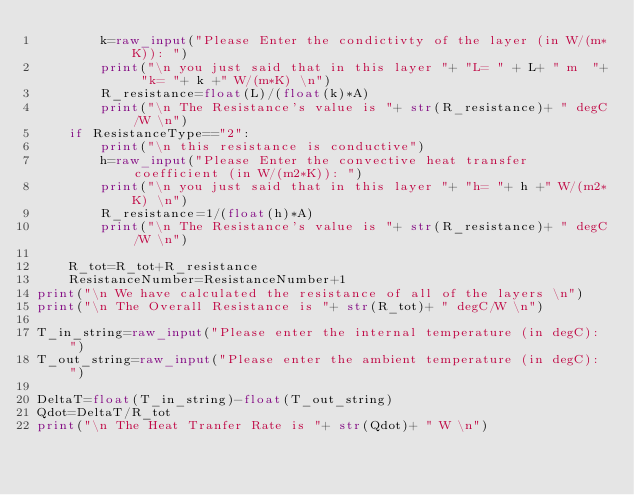Convert code to text. <code><loc_0><loc_0><loc_500><loc_500><_Python_>        k=raw_input("Please Enter the condictivty of the layer (in W/(m*K)): ")
        print("\n you just said that in this layer "+ "L= " + L+ " m  "+ "k= "+ k +" W/(m*K) \n")
        R_resistance=float(L)/(float(k)*A)
        print("\n The Resistance's value is "+ str(R_resistance)+ " degC/W \n")
    if ResistanceType=="2":
        print("\n this resistance is conductive")
        h=raw_input("Please Enter the convective heat transfer coefficient (in W/(m2*K)): ")
        print("\n you just said that in this layer "+ "h= "+ h +" W/(m2*K) \n")
        R_resistance=1/(float(h)*A)
        print("\n The Resistance's value is "+ str(R_resistance)+ " degC/W \n")

    R_tot=R_tot+R_resistance
    ResistanceNumber=ResistanceNumber+1
print("\n We have calculated the resistance of all of the layers \n")
print("\n The Overall Resistance is "+ str(R_tot)+ " degC/W \n")

T_in_string=raw_input("Please enter the internal temperature (in degC): ")
T_out_string=raw_input("Please enter the ambient temperature (in degC): ")

DeltaT=float(T_in_string)-float(T_out_string)
Qdot=DeltaT/R_tot
print("\n The Heat Tranfer Rate is "+ str(Qdot)+ " W \n")
</code> 